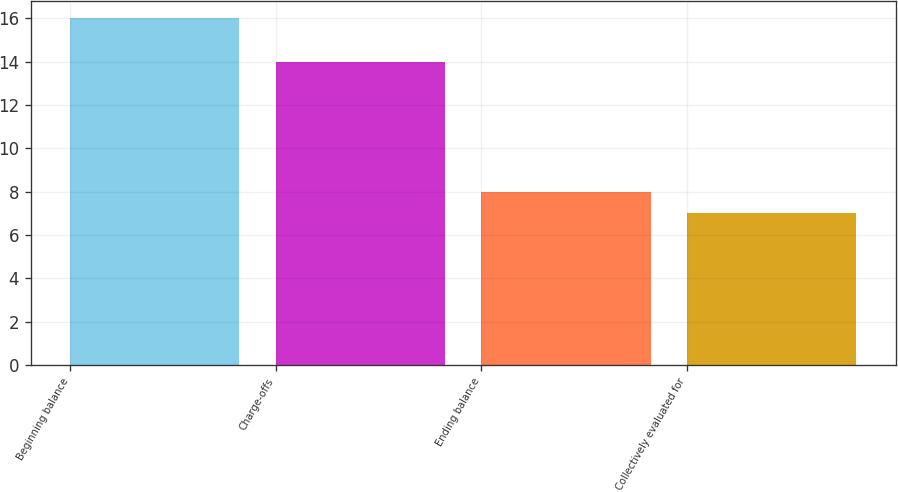Convert chart. <chart><loc_0><loc_0><loc_500><loc_500><bar_chart><fcel>Beginning balance<fcel>Charge-offs<fcel>Ending balance<fcel>Collectively evaluated for<nl><fcel>16<fcel>14<fcel>8<fcel>7<nl></chart> 